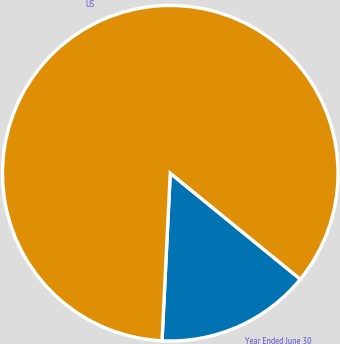Convert chart to OTSL. <chart><loc_0><loc_0><loc_500><loc_500><pie_chart><fcel>Year Ended June 30<fcel>US<nl><fcel>14.9%<fcel>85.1%<nl></chart> 